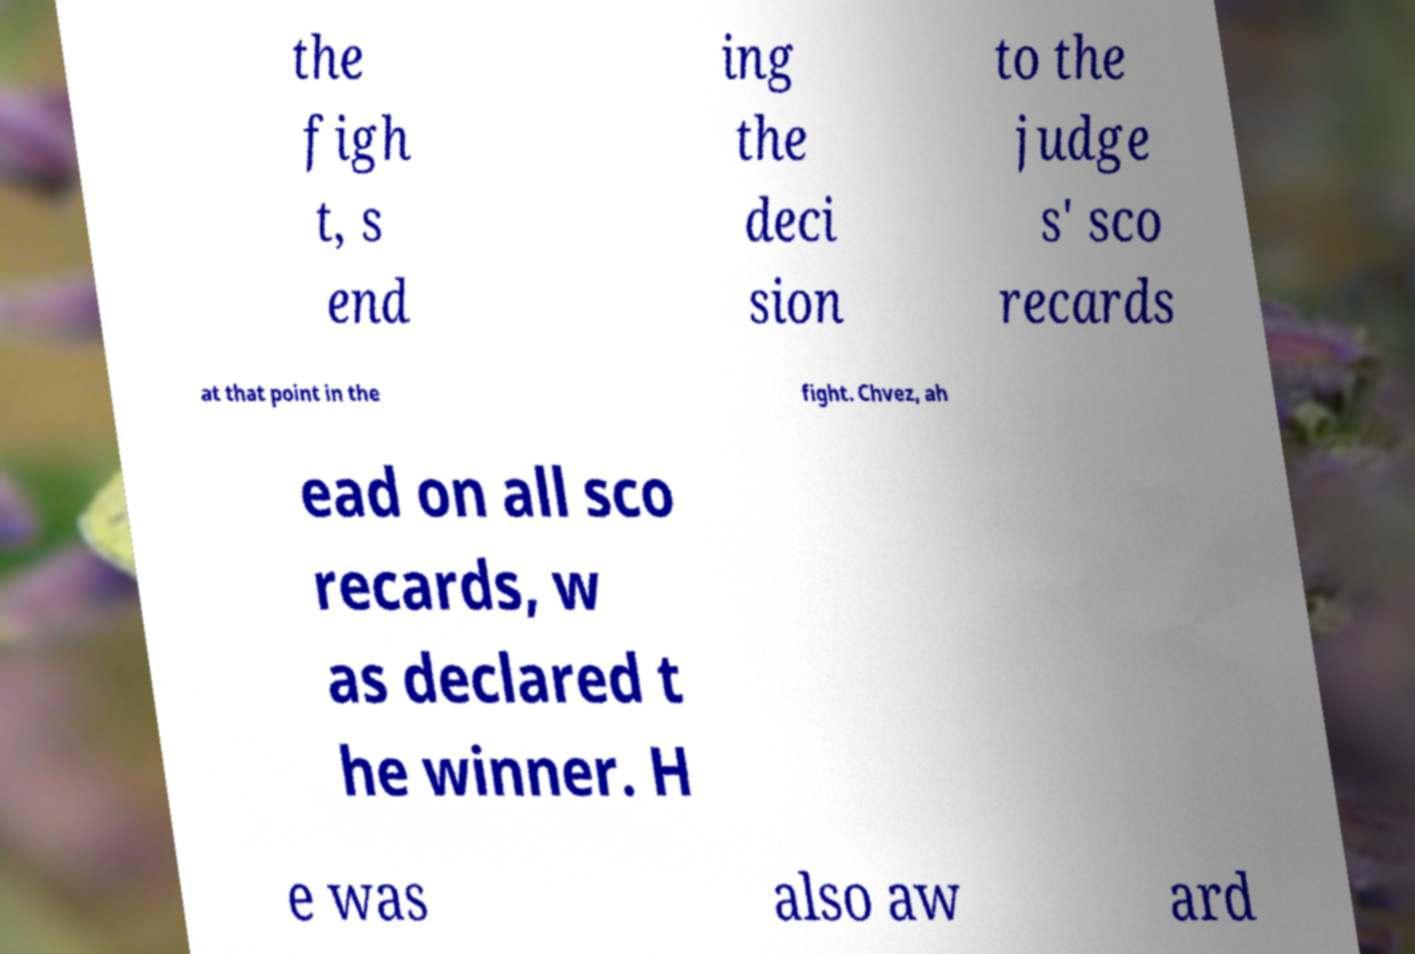What messages or text are displayed in this image? I need them in a readable, typed format. the figh t, s end ing the deci sion to the judge s' sco recards at that point in the fight. Chvez, ah ead on all sco recards, w as declared t he winner. H e was also aw ard 